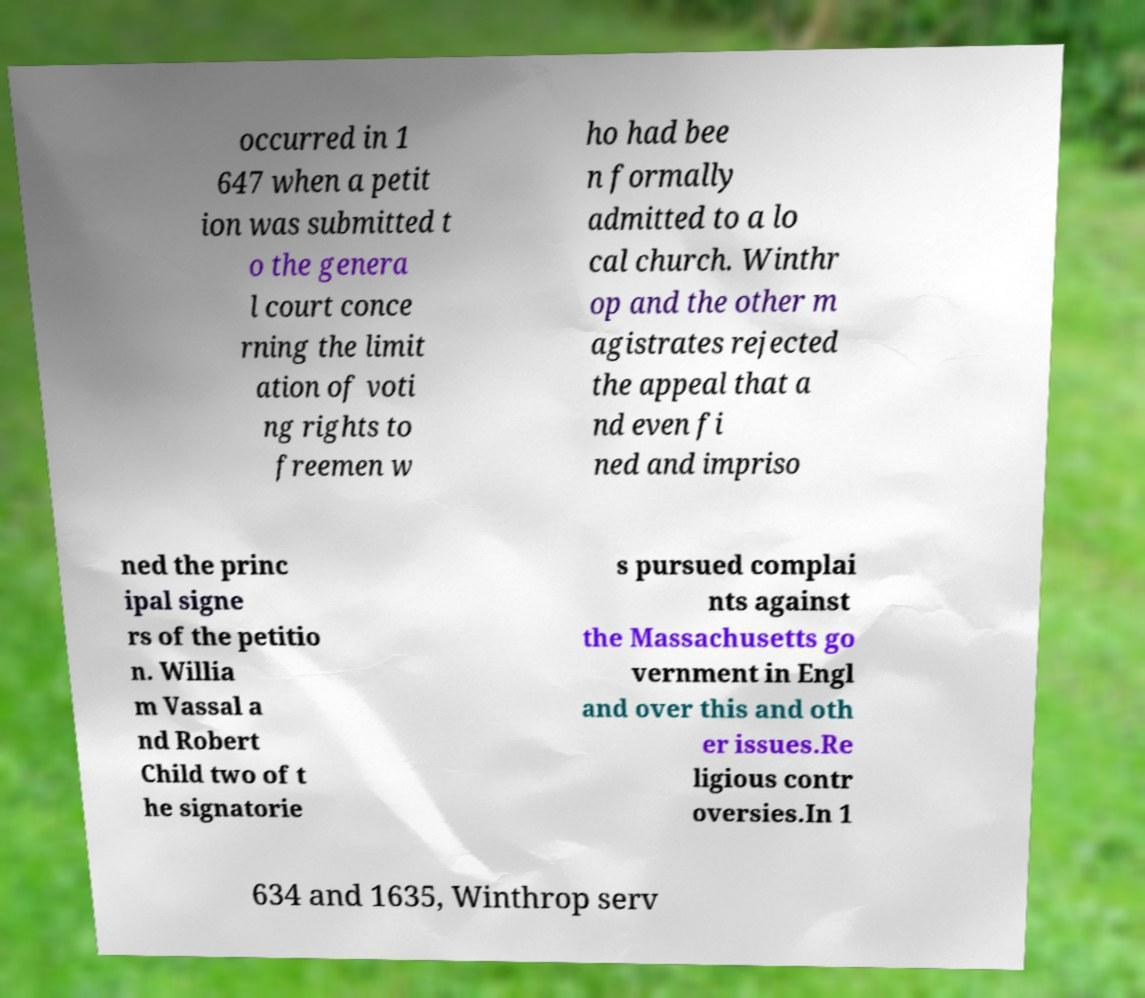For documentation purposes, I need the text within this image transcribed. Could you provide that? occurred in 1 647 when a petit ion was submitted t o the genera l court conce rning the limit ation of voti ng rights to freemen w ho had bee n formally admitted to a lo cal church. Winthr op and the other m agistrates rejected the appeal that a nd even fi ned and impriso ned the princ ipal signe rs of the petitio n. Willia m Vassal a nd Robert Child two of t he signatorie s pursued complai nts against the Massachusetts go vernment in Engl and over this and oth er issues.Re ligious contr oversies.In 1 634 and 1635, Winthrop serv 